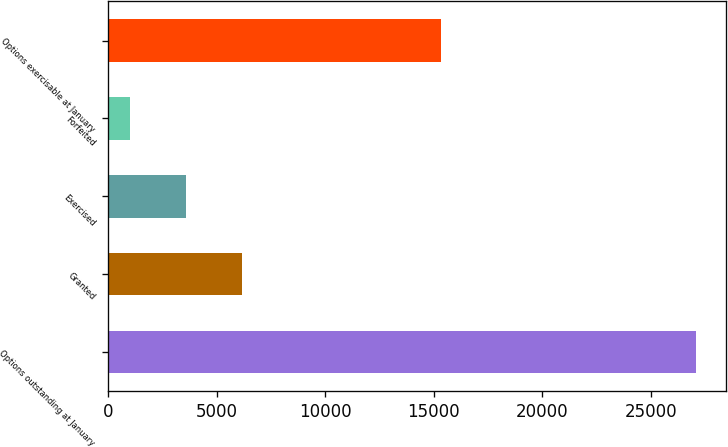Convert chart to OTSL. <chart><loc_0><loc_0><loc_500><loc_500><bar_chart><fcel>Options outstanding at January<fcel>Granted<fcel>Exercised<fcel>Forfeited<fcel>Options exercisable at January<nl><fcel>27086.7<fcel>6172.4<fcel>3591.7<fcel>1011<fcel>15325<nl></chart> 